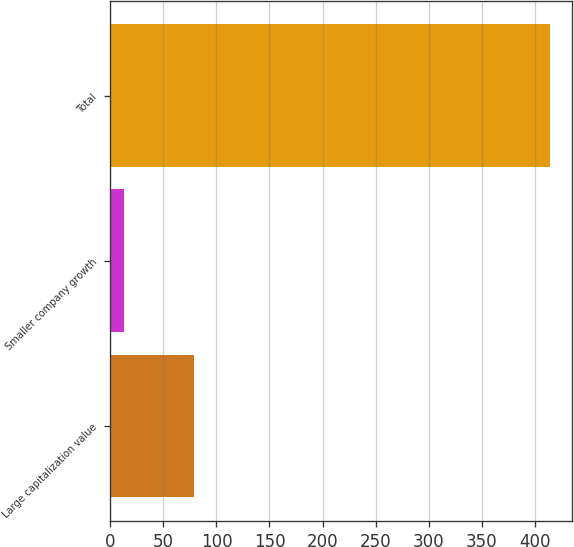<chart> <loc_0><loc_0><loc_500><loc_500><bar_chart><fcel>Large capitalization value<fcel>Smaller company growth<fcel>Total<nl><fcel>79<fcel>13<fcel>414<nl></chart> 